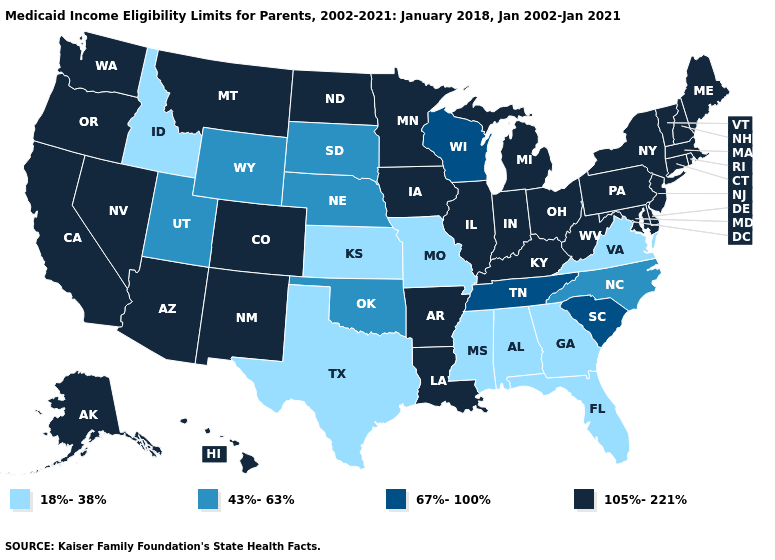Does Iowa have a higher value than New Jersey?
Write a very short answer. No. Name the states that have a value in the range 105%-221%?
Write a very short answer. Alaska, Arizona, Arkansas, California, Colorado, Connecticut, Delaware, Hawaii, Illinois, Indiana, Iowa, Kentucky, Louisiana, Maine, Maryland, Massachusetts, Michigan, Minnesota, Montana, Nevada, New Hampshire, New Jersey, New Mexico, New York, North Dakota, Ohio, Oregon, Pennsylvania, Rhode Island, Vermont, Washington, West Virginia. Among the states that border Colorado , which have the highest value?
Answer briefly. Arizona, New Mexico. What is the value of Oklahoma?
Short answer required. 43%-63%. Does Mississippi have the lowest value in the USA?
Short answer required. Yes. Among the states that border Virginia , which have the highest value?
Short answer required. Kentucky, Maryland, West Virginia. What is the highest value in the USA?
Short answer required. 105%-221%. Does the first symbol in the legend represent the smallest category?
Short answer required. Yes. Which states have the highest value in the USA?
Keep it brief. Alaska, Arizona, Arkansas, California, Colorado, Connecticut, Delaware, Hawaii, Illinois, Indiana, Iowa, Kentucky, Louisiana, Maine, Maryland, Massachusetts, Michigan, Minnesota, Montana, Nevada, New Hampshire, New Jersey, New Mexico, New York, North Dakota, Ohio, Oregon, Pennsylvania, Rhode Island, Vermont, Washington, West Virginia. What is the value of New Hampshire?
Be succinct. 105%-221%. Name the states that have a value in the range 67%-100%?
Short answer required. South Carolina, Tennessee, Wisconsin. Which states have the highest value in the USA?
Quick response, please. Alaska, Arizona, Arkansas, California, Colorado, Connecticut, Delaware, Hawaii, Illinois, Indiana, Iowa, Kentucky, Louisiana, Maine, Maryland, Massachusetts, Michigan, Minnesota, Montana, Nevada, New Hampshire, New Jersey, New Mexico, New York, North Dakota, Ohio, Oregon, Pennsylvania, Rhode Island, Vermont, Washington, West Virginia. 